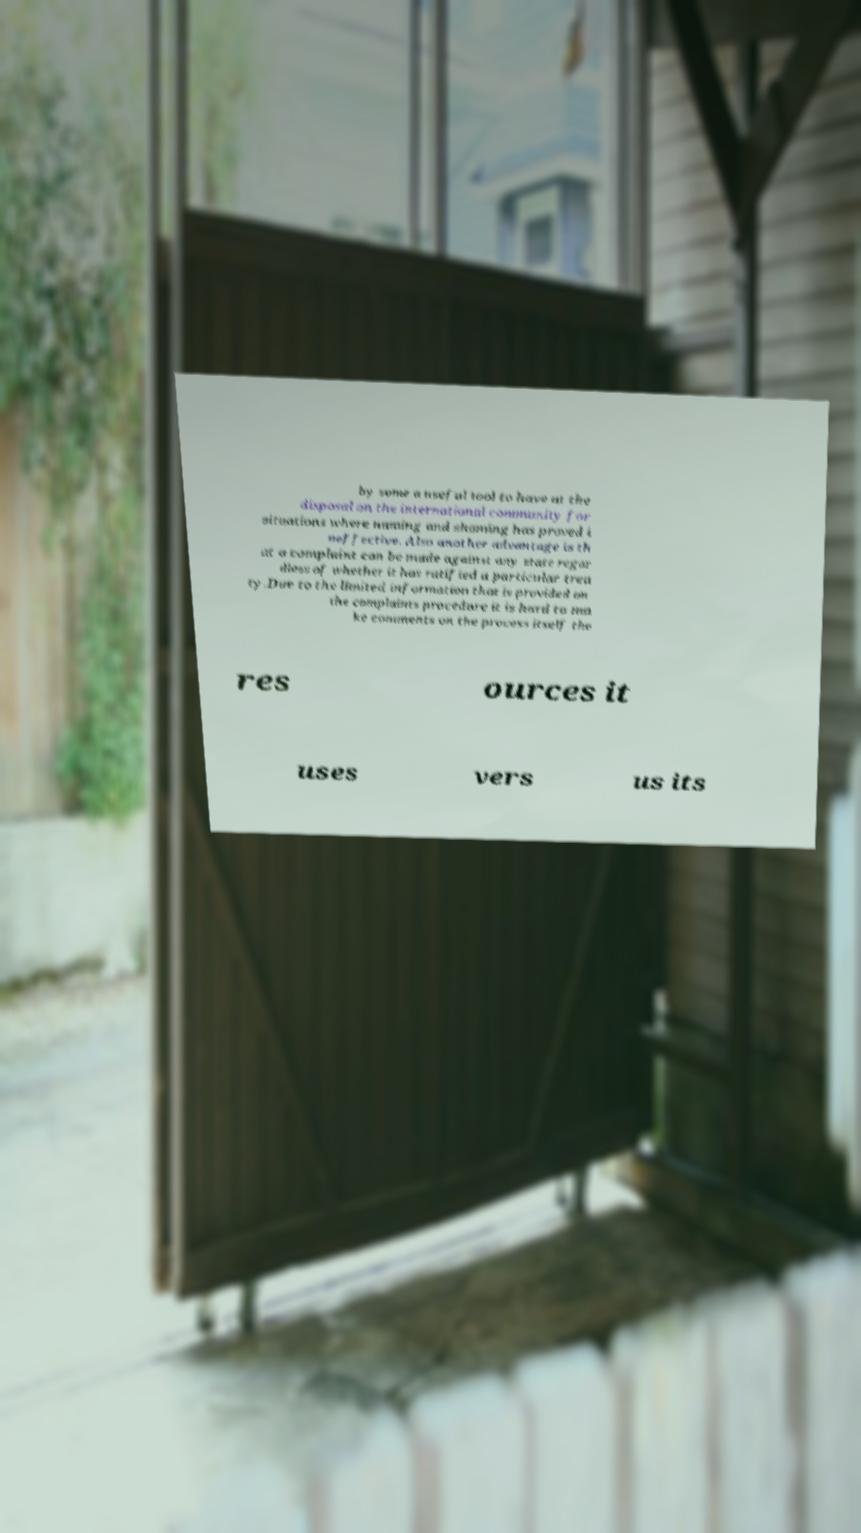Please identify and transcribe the text found in this image. by some a useful tool to have at the disposal on the international community for situations where naming and shaming has proved i neffective. Also another advantage is th at a complaint can be made against any state regar dless of whether it has ratified a particular trea ty.Due to the limited information that is provided on the complaints procedure it is hard to ma ke comments on the process itself the res ources it uses vers us its 